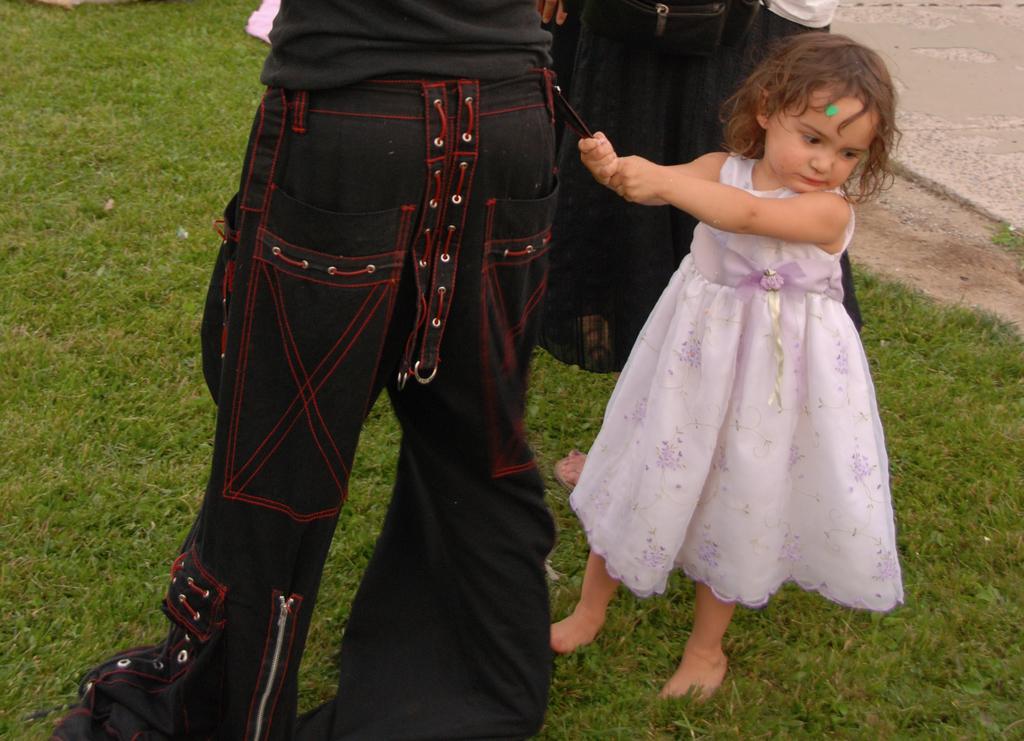In one or two sentences, can you explain what this image depicts? In this picture there is a girl who is wearing pink dress, beside her I can see two persons who are wearing black dress. Three of them are standing on the grass. 